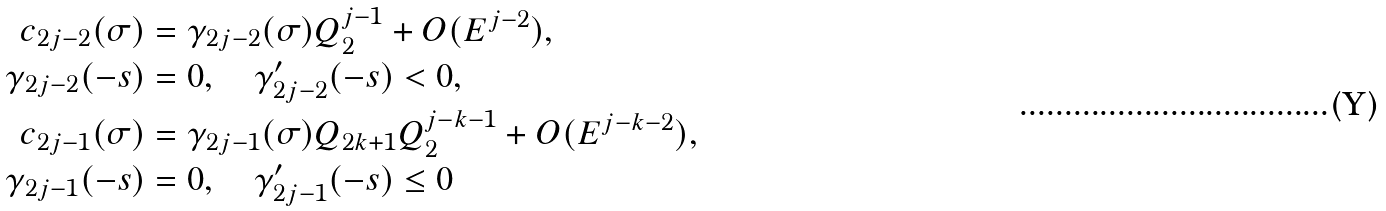<formula> <loc_0><loc_0><loc_500><loc_500>c _ { 2 j - 2 } ( \sigma ) & = \gamma _ { 2 j - 2 } ( \sigma ) Q _ { 2 } ^ { j - 1 } + O ( E ^ { j - 2 } ) , \\ \gamma _ { 2 j - 2 } ( - s ) & = 0 , \quad \gamma _ { 2 j - 2 } ^ { \prime } ( - s ) < 0 , \\ c _ { 2 j - 1 } ( \sigma ) & = \gamma _ { 2 j - 1 } ( \sigma ) Q _ { 2 k + 1 } Q _ { 2 } ^ { j - k - 1 } + O ( E ^ { j - k - 2 } ) , \\ \gamma _ { 2 j - 1 } ( - s ) & = 0 , \quad \gamma _ { 2 j - 1 } ^ { \prime } ( - s ) \leq 0</formula> 